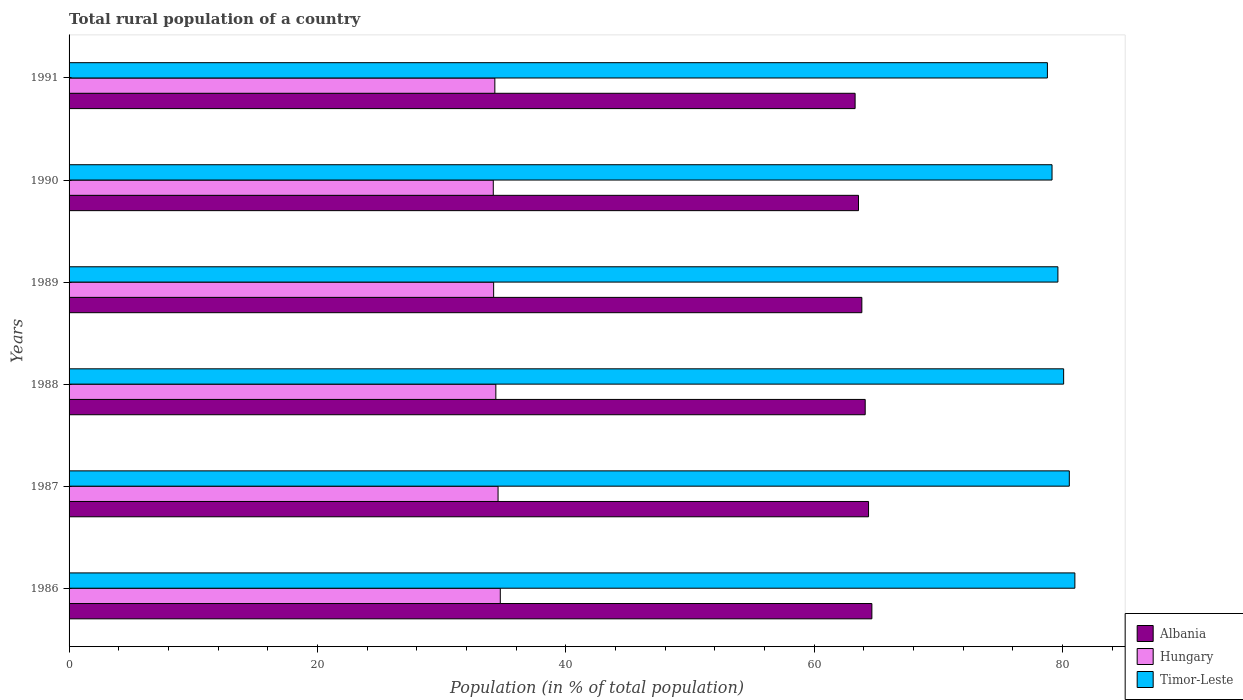How many groups of bars are there?
Keep it short and to the point. 6. Are the number of bars on each tick of the Y-axis equal?
Make the answer very short. Yes. In how many cases, is the number of bars for a given year not equal to the number of legend labels?
Ensure brevity in your answer.  0. What is the rural population in Timor-Leste in 1989?
Ensure brevity in your answer.  79.63. Across all years, what is the maximum rural population in Hungary?
Your response must be concise. 34.73. Across all years, what is the minimum rural population in Timor-Leste?
Offer a terse response. 78.78. In which year was the rural population in Albania maximum?
Offer a terse response. 1986. What is the total rural population in Timor-Leste in the graph?
Your answer should be compact. 479.21. What is the difference between the rural population in Hungary in 1986 and that in 1988?
Provide a succinct answer. 0.36. What is the difference between the rural population in Albania in 1991 and the rural population in Hungary in 1988?
Offer a terse response. 28.93. What is the average rural population in Hungary per year?
Provide a short and direct response. 34.38. In the year 1986, what is the difference between the rural population in Hungary and rural population in Albania?
Your answer should be very brief. -29.92. In how many years, is the rural population in Albania greater than 16 %?
Provide a short and direct response. 6. What is the ratio of the rural population in Albania in 1986 to that in 1987?
Give a very brief answer. 1. Is the difference between the rural population in Hungary in 1990 and 1991 greater than the difference between the rural population in Albania in 1990 and 1991?
Make the answer very short. No. What is the difference between the highest and the second highest rural population in Albania?
Your response must be concise. 0.27. What is the difference between the highest and the lowest rural population in Hungary?
Ensure brevity in your answer.  0.56. In how many years, is the rural population in Hungary greater than the average rural population in Hungary taken over all years?
Your response must be concise. 2. Is the sum of the rural population in Hungary in 1986 and 1988 greater than the maximum rural population in Albania across all years?
Give a very brief answer. Yes. What does the 2nd bar from the top in 1989 represents?
Your response must be concise. Hungary. What does the 2nd bar from the bottom in 1991 represents?
Offer a terse response. Hungary. Is it the case that in every year, the sum of the rural population in Albania and rural population in Hungary is greater than the rural population in Timor-Leste?
Offer a very short reply. Yes. How many bars are there?
Offer a very short reply. 18. How many years are there in the graph?
Ensure brevity in your answer.  6. Does the graph contain grids?
Offer a terse response. No. How many legend labels are there?
Give a very brief answer. 3. How are the legend labels stacked?
Make the answer very short. Vertical. What is the title of the graph?
Make the answer very short. Total rural population of a country. What is the label or title of the X-axis?
Offer a very short reply. Population (in % of total population). What is the Population (in % of total population) of Albania in 1986?
Keep it short and to the point. 64.65. What is the Population (in % of total population) of Hungary in 1986?
Offer a terse response. 34.73. What is the Population (in % of total population) of Timor-Leste in 1986?
Offer a terse response. 81. What is the Population (in % of total population) of Albania in 1987?
Your response must be concise. 64.38. What is the Population (in % of total population) of Hungary in 1987?
Your answer should be very brief. 34.55. What is the Population (in % of total population) of Timor-Leste in 1987?
Your response must be concise. 80.55. What is the Population (in % of total population) in Albania in 1988?
Offer a very short reply. 64.11. What is the Population (in % of total population) in Hungary in 1988?
Make the answer very short. 34.37. What is the Population (in % of total population) in Timor-Leste in 1988?
Give a very brief answer. 80.09. What is the Population (in % of total population) in Albania in 1989?
Ensure brevity in your answer.  63.84. What is the Population (in % of total population) of Hungary in 1989?
Keep it short and to the point. 34.19. What is the Population (in % of total population) in Timor-Leste in 1989?
Offer a very short reply. 79.63. What is the Population (in % of total population) in Albania in 1990?
Provide a short and direct response. 63.57. What is the Population (in % of total population) in Hungary in 1990?
Your answer should be very brief. 34.16. What is the Population (in % of total population) in Timor-Leste in 1990?
Your answer should be very brief. 79.16. What is the Population (in % of total population) in Albania in 1991?
Give a very brief answer. 63.3. What is the Population (in % of total population) in Hungary in 1991?
Your answer should be very brief. 34.29. What is the Population (in % of total population) of Timor-Leste in 1991?
Your answer should be compact. 78.78. Across all years, what is the maximum Population (in % of total population) of Albania?
Make the answer very short. 64.65. Across all years, what is the maximum Population (in % of total population) of Hungary?
Give a very brief answer. 34.73. Across all years, what is the maximum Population (in % of total population) of Timor-Leste?
Provide a succinct answer. 81. Across all years, what is the minimum Population (in % of total population) in Albania?
Keep it short and to the point. 63.3. Across all years, what is the minimum Population (in % of total population) in Hungary?
Ensure brevity in your answer.  34.16. Across all years, what is the minimum Population (in % of total population) in Timor-Leste?
Your answer should be very brief. 78.78. What is the total Population (in % of total population) of Albania in the graph?
Make the answer very short. 383.86. What is the total Population (in % of total population) in Hungary in the graph?
Make the answer very short. 206.28. What is the total Population (in % of total population) in Timor-Leste in the graph?
Provide a short and direct response. 479.21. What is the difference between the Population (in % of total population) in Albania in 1986 and that in 1987?
Provide a succinct answer. 0.27. What is the difference between the Population (in % of total population) of Hungary in 1986 and that in 1987?
Your response must be concise. 0.18. What is the difference between the Population (in % of total population) in Timor-Leste in 1986 and that in 1987?
Make the answer very short. 0.45. What is the difference between the Population (in % of total population) in Albania in 1986 and that in 1988?
Ensure brevity in your answer.  0.54. What is the difference between the Population (in % of total population) of Hungary in 1986 and that in 1988?
Give a very brief answer. 0.36. What is the difference between the Population (in % of total population) of Timor-Leste in 1986 and that in 1988?
Offer a terse response. 0.9. What is the difference between the Population (in % of total population) in Albania in 1986 and that in 1989?
Offer a terse response. 0.81. What is the difference between the Population (in % of total population) of Hungary in 1986 and that in 1989?
Keep it short and to the point. 0.54. What is the difference between the Population (in % of total population) in Timor-Leste in 1986 and that in 1989?
Make the answer very short. 1.37. What is the difference between the Population (in % of total population) of Albania in 1986 and that in 1990?
Your answer should be very brief. 1.08. What is the difference between the Population (in % of total population) of Hungary in 1986 and that in 1990?
Your response must be concise. 0.56. What is the difference between the Population (in % of total population) of Timor-Leste in 1986 and that in 1990?
Your response must be concise. 1.84. What is the difference between the Population (in % of total population) of Albania in 1986 and that in 1991?
Your answer should be very brief. 1.35. What is the difference between the Population (in % of total population) in Hungary in 1986 and that in 1991?
Your answer should be compact. 0.44. What is the difference between the Population (in % of total population) of Timor-Leste in 1986 and that in 1991?
Make the answer very short. 2.21. What is the difference between the Population (in % of total population) in Albania in 1987 and that in 1988?
Ensure brevity in your answer.  0.27. What is the difference between the Population (in % of total population) in Hungary in 1987 and that in 1988?
Your answer should be very brief. 0.18. What is the difference between the Population (in % of total population) of Timor-Leste in 1987 and that in 1988?
Provide a succinct answer. 0.46. What is the difference between the Population (in % of total population) of Albania in 1987 and that in 1989?
Provide a succinct answer. 0.54. What is the difference between the Population (in % of total population) in Hungary in 1987 and that in 1989?
Offer a terse response. 0.36. What is the difference between the Population (in % of total population) of Timor-Leste in 1987 and that in 1989?
Your response must be concise. 0.92. What is the difference between the Population (in % of total population) of Albania in 1987 and that in 1990?
Keep it short and to the point. 0.81. What is the difference between the Population (in % of total population) in Hungary in 1987 and that in 1990?
Provide a short and direct response. 0.39. What is the difference between the Population (in % of total population) of Timor-Leste in 1987 and that in 1990?
Ensure brevity in your answer.  1.39. What is the difference between the Population (in % of total population) in Albania in 1987 and that in 1991?
Keep it short and to the point. 1.08. What is the difference between the Population (in % of total population) in Hungary in 1987 and that in 1991?
Ensure brevity in your answer.  0.26. What is the difference between the Population (in % of total population) in Timor-Leste in 1987 and that in 1991?
Provide a succinct answer. 1.76. What is the difference between the Population (in % of total population) in Albania in 1988 and that in 1989?
Keep it short and to the point. 0.27. What is the difference between the Population (in % of total population) in Hungary in 1988 and that in 1989?
Provide a succinct answer. 0.18. What is the difference between the Population (in % of total population) in Timor-Leste in 1988 and that in 1989?
Make the answer very short. 0.46. What is the difference between the Population (in % of total population) in Albania in 1988 and that in 1990?
Ensure brevity in your answer.  0.54. What is the difference between the Population (in % of total population) in Hungary in 1988 and that in 1990?
Keep it short and to the point. 0.21. What is the difference between the Population (in % of total population) in Timor-Leste in 1988 and that in 1990?
Ensure brevity in your answer.  0.94. What is the difference between the Population (in % of total population) in Albania in 1988 and that in 1991?
Your answer should be very brief. 0.81. What is the difference between the Population (in % of total population) in Hungary in 1988 and that in 1991?
Your answer should be compact. 0.08. What is the difference between the Population (in % of total population) in Timor-Leste in 1988 and that in 1991?
Provide a short and direct response. 1.31. What is the difference between the Population (in % of total population) in Albania in 1989 and that in 1990?
Keep it short and to the point. 0.27. What is the difference between the Population (in % of total population) of Hungary in 1989 and that in 1990?
Your answer should be very brief. 0.03. What is the difference between the Population (in % of total population) of Timor-Leste in 1989 and that in 1990?
Make the answer very short. 0.47. What is the difference between the Population (in % of total population) in Albania in 1989 and that in 1991?
Provide a short and direct response. 0.54. What is the difference between the Population (in % of total population) of Hungary in 1989 and that in 1991?
Make the answer very short. -0.1. What is the difference between the Population (in % of total population) of Timor-Leste in 1989 and that in 1991?
Provide a short and direct response. 0.84. What is the difference between the Population (in % of total population) of Albania in 1990 and that in 1991?
Give a very brief answer. 0.27. What is the difference between the Population (in % of total population) of Hungary in 1990 and that in 1991?
Make the answer very short. -0.12. What is the difference between the Population (in % of total population) of Timor-Leste in 1990 and that in 1991?
Give a very brief answer. 0.37. What is the difference between the Population (in % of total population) in Albania in 1986 and the Population (in % of total population) in Hungary in 1987?
Your response must be concise. 30.1. What is the difference between the Population (in % of total population) of Albania in 1986 and the Population (in % of total population) of Timor-Leste in 1987?
Keep it short and to the point. -15.9. What is the difference between the Population (in % of total population) in Hungary in 1986 and the Population (in % of total population) in Timor-Leste in 1987?
Keep it short and to the point. -45.82. What is the difference between the Population (in % of total population) of Albania in 1986 and the Population (in % of total population) of Hungary in 1988?
Make the answer very short. 30.28. What is the difference between the Population (in % of total population) of Albania in 1986 and the Population (in % of total population) of Timor-Leste in 1988?
Make the answer very short. -15.44. What is the difference between the Population (in % of total population) of Hungary in 1986 and the Population (in % of total population) of Timor-Leste in 1988?
Keep it short and to the point. -45.37. What is the difference between the Population (in % of total population) in Albania in 1986 and the Population (in % of total population) in Hungary in 1989?
Your response must be concise. 30.46. What is the difference between the Population (in % of total population) of Albania in 1986 and the Population (in % of total population) of Timor-Leste in 1989?
Give a very brief answer. -14.98. What is the difference between the Population (in % of total population) of Hungary in 1986 and the Population (in % of total population) of Timor-Leste in 1989?
Make the answer very short. -44.9. What is the difference between the Population (in % of total population) in Albania in 1986 and the Population (in % of total population) in Hungary in 1990?
Your response must be concise. 30.49. What is the difference between the Population (in % of total population) in Albania in 1986 and the Population (in % of total population) in Timor-Leste in 1990?
Offer a terse response. -14.51. What is the difference between the Population (in % of total population) in Hungary in 1986 and the Population (in % of total population) in Timor-Leste in 1990?
Your response must be concise. -44.43. What is the difference between the Population (in % of total population) in Albania in 1986 and the Population (in % of total population) in Hungary in 1991?
Ensure brevity in your answer.  30.36. What is the difference between the Population (in % of total population) in Albania in 1986 and the Population (in % of total population) in Timor-Leste in 1991?
Your answer should be compact. -14.13. What is the difference between the Population (in % of total population) of Hungary in 1986 and the Population (in % of total population) of Timor-Leste in 1991?
Offer a very short reply. -44.06. What is the difference between the Population (in % of total population) in Albania in 1987 and the Population (in % of total population) in Hungary in 1988?
Make the answer very short. 30.01. What is the difference between the Population (in % of total population) in Albania in 1987 and the Population (in % of total population) in Timor-Leste in 1988?
Keep it short and to the point. -15.71. What is the difference between the Population (in % of total population) in Hungary in 1987 and the Population (in % of total population) in Timor-Leste in 1988?
Your response must be concise. -45.55. What is the difference between the Population (in % of total population) in Albania in 1987 and the Population (in % of total population) in Hungary in 1989?
Make the answer very short. 30.19. What is the difference between the Population (in % of total population) of Albania in 1987 and the Population (in % of total population) of Timor-Leste in 1989?
Keep it short and to the point. -15.25. What is the difference between the Population (in % of total population) in Hungary in 1987 and the Population (in % of total population) in Timor-Leste in 1989?
Make the answer very short. -45.08. What is the difference between the Population (in % of total population) of Albania in 1987 and the Population (in % of total population) of Hungary in 1990?
Offer a very short reply. 30.22. What is the difference between the Population (in % of total population) in Albania in 1987 and the Population (in % of total population) in Timor-Leste in 1990?
Provide a short and direct response. -14.78. What is the difference between the Population (in % of total population) of Hungary in 1987 and the Population (in % of total population) of Timor-Leste in 1990?
Offer a very short reply. -44.61. What is the difference between the Population (in % of total population) of Albania in 1987 and the Population (in % of total population) of Hungary in 1991?
Provide a succinct answer. 30.09. What is the difference between the Population (in % of total population) in Albania in 1987 and the Population (in % of total population) in Timor-Leste in 1991?
Your answer should be very brief. -14.4. What is the difference between the Population (in % of total population) in Hungary in 1987 and the Population (in % of total population) in Timor-Leste in 1991?
Your answer should be compact. -44.24. What is the difference between the Population (in % of total population) in Albania in 1988 and the Population (in % of total population) in Hungary in 1989?
Your answer should be very brief. 29.92. What is the difference between the Population (in % of total population) in Albania in 1988 and the Population (in % of total population) in Timor-Leste in 1989?
Your answer should be compact. -15.52. What is the difference between the Population (in % of total population) in Hungary in 1988 and the Population (in % of total population) in Timor-Leste in 1989?
Provide a short and direct response. -45.26. What is the difference between the Population (in % of total population) of Albania in 1988 and the Population (in % of total population) of Hungary in 1990?
Make the answer very short. 29.95. What is the difference between the Population (in % of total population) of Albania in 1988 and the Population (in % of total population) of Timor-Leste in 1990?
Your response must be concise. -15.05. What is the difference between the Population (in % of total population) in Hungary in 1988 and the Population (in % of total population) in Timor-Leste in 1990?
Give a very brief answer. -44.79. What is the difference between the Population (in % of total population) in Albania in 1988 and the Population (in % of total population) in Hungary in 1991?
Make the answer very short. 29.82. What is the difference between the Population (in % of total population) of Albania in 1988 and the Population (in % of total population) of Timor-Leste in 1991?
Your response must be concise. -14.67. What is the difference between the Population (in % of total population) of Hungary in 1988 and the Population (in % of total population) of Timor-Leste in 1991?
Your answer should be compact. -44.42. What is the difference between the Population (in % of total population) in Albania in 1989 and the Population (in % of total population) in Hungary in 1990?
Give a very brief answer. 29.68. What is the difference between the Population (in % of total population) of Albania in 1989 and the Population (in % of total population) of Timor-Leste in 1990?
Make the answer very short. -15.32. What is the difference between the Population (in % of total population) in Hungary in 1989 and the Population (in % of total population) in Timor-Leste in 1990?
Keep it short and to the point. -44.97. What is the difference between the Population (in % of total population) of Albania in 1989 and the Population (in % of total population) of Hungary in 1991?
Offer a very short reply. 29.55. What is the difference between the Population (in % of total population) in Albania in 1989 and the Population (in % of total population) in Timor-Leste in 1991?
Ensure brevity in your answer.  -14.94. What is the difference between the Population (in % of total population) in Hungary in 1989 and the Population (in % of total population) in Timor-Leste in 1991?
Your response must be concise. -44.59. What is the difference between the Population (in % of total population) of Albania in 1990 and the Population (in % of total population) of Hungary in 1991?
Your answer should be compact. 29.29. What is the difference between the Population (in % of total population) in Albania in 1990 and the Population (in % of total population) in Timor-Leste in 1991?
Keep it short and to the point. -15.21. What is the difference between the Population (in % of total population) of Hungary in 1990 and the Population (in % of total population) of Timor-Leste in 1991?
Give a very brief answer. -44.62. What is the average Population (in % of total population) in Albania per year?
Your answer should be compact. 63.98. What is the average Population (in % of total population) in Hungary per year?
Offer a terse response. 34.38. What is the average Population (in % of total population) of Timor-Leste per year?
Provide a succinct answer. 79.87. In the year 1986, what is the difference between the Population (in % of total population) in Albania and Population (in % of total population) in Hungary?
Your answer should be very brief. 29.92. In the year 1986, what is the difference between the Population (in % of total population) of Albania and Population (in % of total population) of Timor-Leste?
Ensure brevity in your answer.  -16.35. In the year 1986, what is the difference between the Population (in % of total population) of Hungary and Population (in % of total population) of Timor-Leste?
Ensure brevity in your answer.  -46.27. In the year 1987, what is the difference between the Population (in % of total population) of Albania and Population (in % of total population) of Hungary?
Provide a succinct answer. 29.83. In the year 1987, what is the difference between the Population (in % of total population) in Albania and Population (in % of total population) in Timor-Leste?
Your answer should be compact. -16.17. In the year 1987, what is the difference between the Population (in % of total population) in Hungary and Population (in % of total population) in Timor-Leste?
Your answer should be very brief. -46. In the year 1988, what is the difference between the Population (in % of total population) in Albania and Population (in % of total population) in Hungary?
Your answer should be very brief. 29.74. In the year 1988, what is the difference between the Population (in % of total population) of Albania and Population (in % of total population) of Timor-Leste?
Offer a very short reply. -15.98. In the year 1988, what is the difference between the Population (in % of total population) of Hungary and Population (in % of total population) of Timor-Leste?
Offer a very short reply. -45.73. In the year 1989, what is the difference between the Population (in % of total population) in Albania and Population (in % of total population) in Hungary?
Offer a very short reply. 29.65. In the year 1989, what is the difference between the Population (in % of total population) in Albania and Population (in % of total population) in Timor-Leste?
Give a very brief answer. -15.79. In the year 1989, what is the difference between the Population (in % of total population) of Hungary and Population (in % of total population) of Timor-Leste?
Your response must be concise. -45.44. In the year 1990, what is the difference between the Population (in % of total population) of Albania and Population (in % of total population) of Hungary?
Keep it short and to the point. 29.41. In the year 1990, what is the difference between the Population (in % of total population) of Albania and Population (in % of total population) of Timor-Leste?
Your answer should be compact. -15.59. In the year 1990, what is the difference between the Population (in % of total population) in Hungary and Population (in % of total population) in Timor-Leste?
Provide a succinct answer. -45. In the year 1991, what is the difference between the Population (in % of total population) in Albania and Population (in % of total population) in Hungary?
Ensure brevity in your answer.  29.01. In the year 1991, what is the difference between the Population (in % of total population) of Albania and Population (in % of total population) of Timor-Leste?
Your answer should be compact. -15.48. In the year 1991, what is the difference between the Population (in % of total population) in Hungary and Population (in % of total population) in Timor-Leste?
Your answer should be very brief. -44.5. What is the ratio of the Population (in % of total population) in Albania in 1986 to that in 1987?
Your answer should be very brief. 1. What is the ratio of the Population (in % of total population) of Hungary in 1986 to that in 1987?
Offer a very short reply. 1.01. What is the ratio of the Population (in % of total population) of Timor-Leste in 1986 to that in 1987?
Provide a succinct answer. 1.01. What is the ratio of the Population (in % of total population) in Albania in 1986 to that in 1988?
Ensure brevity in your answer.  1.01. What is the ratio of the Population (in % of total population) of Hungary in 1986 to that in 1988?
Offer a terse response. 1.01. What is the ratio of the Population (in % of total population) in Timor-Leste in 1986 to that in 1988?
Your response must be concise. 1.01. What is the ratio of the Population (in % of total population) of Albania in 1986 to that in 1989?
Ensure brevity in your answer.  1.01. What is the ratio of the Population (in % of total population) of Hungary in 1986 to that in 1989?
Your response must be concise. 1.02. What is the ratio of the Population (in % of total population) in Timor-Leste in 1986 to that in 1989?
Provide a short and direct response. 1.02. What is the ratio of the Population (in % of total population) of Hungary in 1986 to that in 1990?
Offer a terse response. 1.02. What is the ratio of the Population (in % of total population) of Timor-Leste in 1986 to that in 1990?
Offer a very short reply. 1.02. What is the ratio of the Population (in % of total population) in Albania in 1986 to that in 1991?
Offer a very short reply. 1.02. What is the ratio of the Population (in % of total population) of Hungary in 1986 to that in 1991?
Your response must be concise. 1.01. What is the ratio of the Population (in % of total population) of Timor-Leste in 1986 to that in 1991?
Your response must be concise. 1.03. What is the ratio of the Population (in % of total population) of Albania in 1987 to that in 1989?
Provide a succinct answer. 1.01. What is the ratio of the Population (in % of total population) of Hungary in 1987 to that in 1989?
Offer a terse response. 1.01. What is the ratio of the Population (in % of total population) of Timor-Leste in 1987 to that in 1989?
Give a very brief answer. 1.01. What is the ratio of the Population (in % of total population) in Albania in 1987 to that in 1990?
Give a very brief answer. 1.01. What is the ratio of the Population (in % of total population) of Hungary in 1987 to that in 1990?
Your answer should be very brief. 1.01. What is the ratio of the Population (in % of total population) in Timor-Leste in 1987 to that in 1990?
Your response must be concise. 1.02. What is the ratio of the Population (in % of total population) in Albania in 1987 to that in 1991?
Your answer should be compact. 1.02. What is the ratio of the Population (in % of total population) in Hungary in 1987 to that in 1991?
Your answer should be compact. 1.01. What is the ratio of the Population (in % of total population) in Timor-Leste in 1987 to that in 1991?
Keep it short and to the point. 1.02. What is the ratio of the Population (in % of total population) in Albania in 1988 to that in 1990?
Provide a short and direct response. 1.01. What is the ratio of the Population (in % of total population) of Timor-Leste in 1988 to that in 1990?
Ensure brevity in your answer.  1.01. What is the ratio of the Population (in % of total population) in Albania in 1988 to that in 1991?
Offer a very short reply. 1.01. What is the ratio of the Population (in % of total population) of Timor-Leste in 1988 to that in 1991?
Provide a short and direct response. 1.02. What is the ratio of the Population (in % of total population) in Hungary in 1989 to that in 1990?
Offer a terse response. 1. What is the ratio of the Population (in % of total population) in Albania in 1989 to that in 1991?
Ensure brevity in your answer.  1.01. What is the ratio of the Population (in % of total population) in Timor-Leste in 1989 to that in 1991?
Ensure brevity in your answer.  1.01. What is the ratio of the Population (in % of total population) in Hungary in 1990 to that in 1991?
Keep it short and to the point. 1. What is the difference between the highest and the second highest Population (in % of total population) of Albania?
Your answer should be very brief. 0.27. What is the difference between the highest and the second highest Population (in % of total population) in Hungary?
Offer a terse response. 0.18. What is the difference between the highest and the second highest Population (in % of total population) of Timor-Leste?
Give a very brief answer. 0.45. What is the difference between the highest and the lowest Population (in % of total population) in Albania?
Your answer should be very brief. 1.35. What is the difference between the highest and the lowest Population (in % of total population) of Hungary?
Provide a short and direct response. 0.56. What is the difference between the highest and the lowest Population (in % of total population) in Timor-Leste?
Your answer should be very brief. 2.21. 